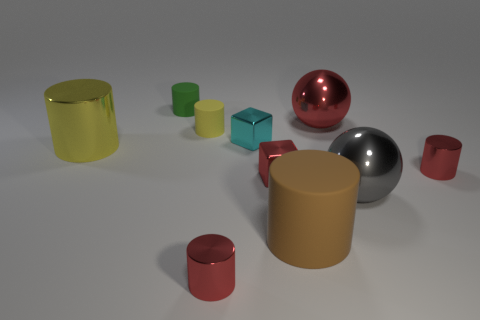There is a tiny cylinder that is the same color as the big shiny cylinder; what is its material?
Your response must be concise. Rubber. What number of matte cylinders have the same color as the large metal cylinder?
Ensure brevity in your answer.  1. How big is the cyan cube?
Your answer should be very brief. Small. Do the large yellow thing and the big gray thing that is on the right side of the small cyan shiny object have the same shape?
Give a very brief answer. No. There is a big cylinder that is the same material as the big gray ball; what is its color?
Provide a short and direct response. Yellow. There is a red shiny object that is behind the yellow shiny thing; what size is it?
Your answer should be compact. Large. Are there fewer big objects to the left of the big brown matte cylinder than red spheres?
Your answer should be very brief. No. Is the large matte object the same color as the big metallic cylinder?
Ensure brevity in your answer.  No. Is there anything else that has the same shape as the brown matte thing?
Offer a very short reply. Yes. Are there fewer big rubber objects than large green shiny cylinders?
Make the answer very short. No. 